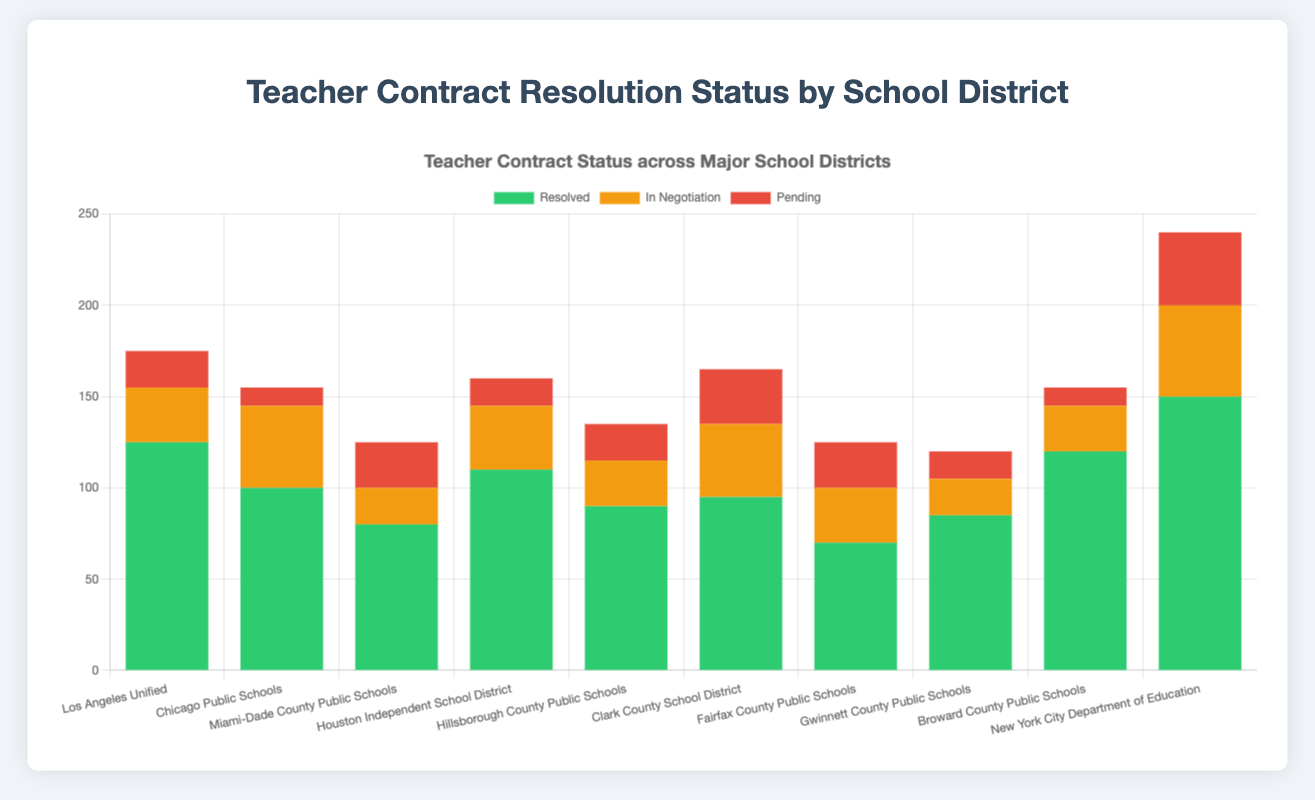Which school district has the highest number of resolved contracts? Look at the bars labeled "Resolved" in the stacked bar chart and identify the highest one. "New York City Department of Education" has the highest green bar.
Answer: New York City Department of Education What is the total number of contracts for Miami-Dade County Public Schools? Add up the values of resolved, in negotiation, and pending contracts for the Miami-Dade County Public Schools. 80 (Resolved) + 20 (In Negotiation) + 25 (Pending) = 125.
Answer: 125 Which school district has more pending contracts: Clark County School District or New York City Department of Education? Compare the heights of the red bars labeled "Pending" for Clark County School District (30) and New York City Department of Education (40).
Answer: New York City Department of Education Is the total number of contracts for Houston Independent School District higher than that for Broward County Public Schools? Add up the contracts for both districts and compare: Houston (110 Resolved + 35 In Negotiation + 15 Pending = 160), Broward (120 Resolved + 25 In Negotiation + 10 Pending = 155). 160 > 155.
Answer: Yes Which school district has the smallest proportion of pending contracts relative to its total number of contracts? Calculate the proportion for each district and compare. For instance, Los Angeles Unified (20 Pending / (125 Resolved + 30 In Negotiation + 20 Pending) ≈ 0.12), and follow the same steps for others. New York City has 40/240 ≈ 0.17, etc. Broward has 10/155 ≈ 0.065. Broward County Public Schools has the smallest proportion.
Answer: Broward County Public Schools What is the average number of resolved contracts across all school districts? Summing all resolved contracts: 125 (Los Angeles Unified) + 100 (Chicago) + 80 (Miami-Dade) + 110 (Houston) + 90 (Hillsborough) + 95 (Clark) + 70 (Fairfax) + 85 (Gwinnett) + 120 (Broward) + 150 (New York City) = 1025. Average is 1025/10 = 102.5.
Answer: 102.5 What is the difference in the number of resolved contracts between the district with the highest and the lowest values? Highest is New York City Department of Education (150), lowest is Fairfax County Public Schools (70). Difference = 150 - 70 = 80.
Answer: 80 Does Hillsborough County Public Schools have more total contracts than Gwinnett County Public Schools? Sum the total for each: Hillsborough (90 Resolved + 25 In Negotiation + 20 Pending = 135), Gwinnett (85 Resolved + 20 In Negotiation + 15 Pending = 120). 135 > 120.
Answer: Yes Which school district has the largest number of contracts still being negotiated? Look at the orange bars labeled "In Negotiation" and identify the highest one. "New York City Department of Education" has the highest orange bar (50).
Answer: New York City Department of Education What is the sum of pending contracts for Los Angeles Unified and Chicago Public Schools? Look at the red bars for both districts and add their values: Los Angeles Unified (20) + Chicago Public Schools (10) = 30.
Answer: 30 